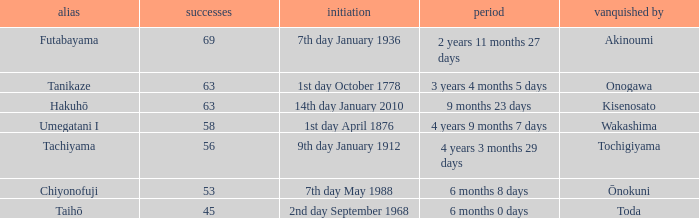What is the Duration for less than 53 consecutive wins? 6 months 0 days. 